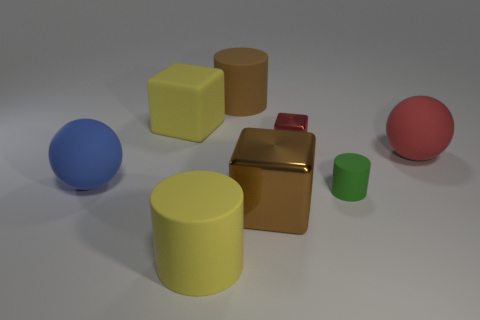There is a large rubber thing in front of the large blue rubber ball; is its color the same as the big cube that is behind the green cylinder?
Your answer should be compact. Yes. Are there more small green things than large purple objects?
Offer a very short reply. Yes. Does the large metallic thing have the same shape as the red metallic thing?
Your answer should be very brief. Yes. What material is the cylinder that is behind the big sphere that is on the right side of the tiny shiny thing?
Give a very brief answer. Rubber. There is another thing that is the same color as the big metal object; what is its material?
Keep it short and to the point. Rubber. Do the yellow matte block and the red metal thing have the same size?
Make the answer very short. No. There is a big brown thing in front of the blue matte ball; is there a big yellow thing that is in front of it?
Your answer should be very brief. Yes. There is a cylinder that is the same color as the big metal thing; what size is it?
Make the answer very short. Large. The brown thing that is behind the large red rubber thing has what shape?
Ensure brevity in your answer.  Cylinder. There is a big cylinder that is behind the big yellow rubber thing that is in front of the green matte cylinder; what number of big rubber cylinders are right of it?
Your answer should be very brief. 0. 